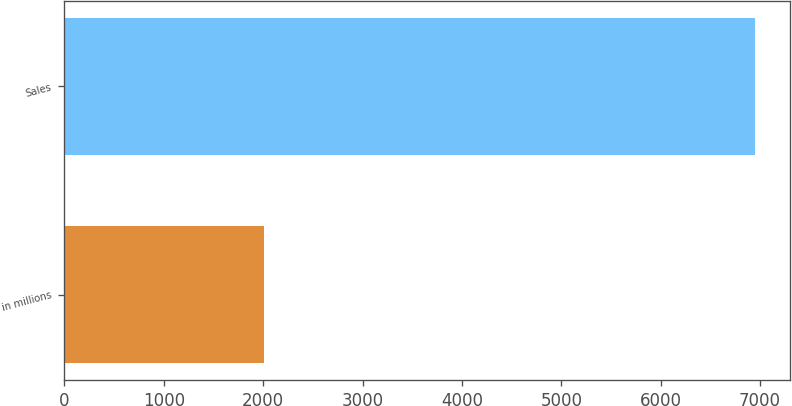Convert chart. <chart><loc_0><loc_0><loc_500><loc_500><bar_chart><fcel>in millions<fcel>Sales<nl><fcel>2012<fcel>6950<nl></chart> 